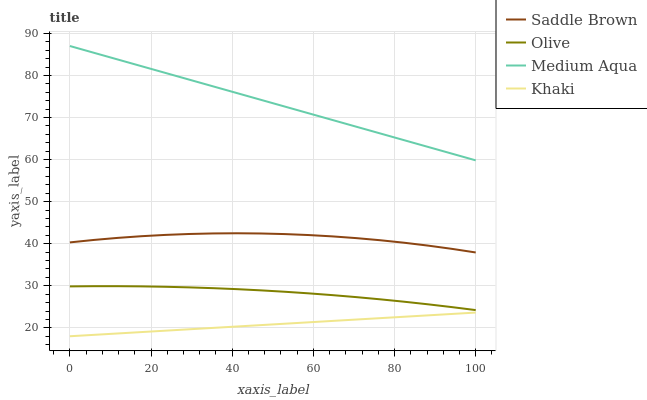Does Khaki have the minimum area under the curve?
Answer yes or no. Yes. Does Medium Aqua have the maximum area under the curve?
Answer yes or no. Yes. Does Medium Aqua have the minimum area under the curve?
Answer yes or no. No. Does Khaki have the maximum area under the curve?
Answer yes or no. No. Is Khaki the smoothest?
Answer yes or no. Yes. Is Saddle Brown the roughest?
Answer yes or no. Yes. Is Medium Aqua the smoothest?
Answer yes or no. No. Is Medium Aqua the roughest?
Answer yes or no. No. Does Khaki have the lowest value?
Answer yes or no. Yes. Does Medium Aqua have the lowest value?
Answer yes or no. No. Does Medium Aqua have the highest value?
Answer yes or no. Yes. Does Khaki have the highest value?
Answer yes or no. No. Is Olive less than Medium Aqua?
Answer yes or no. Yes. Is Medium Aqua greater than Khaki?
Answer yes or no. Yes. Does Olive intersect Medium Aqua?
Answer yes or no. No. 